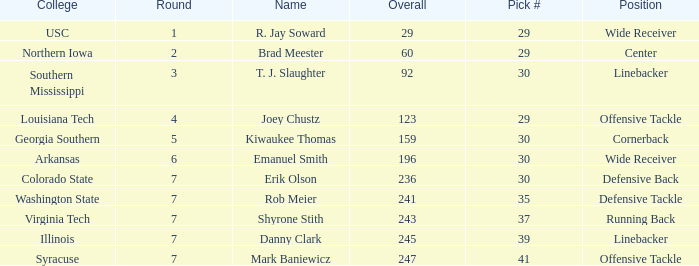What is the highest Pick that is wide receiver with overall of 29? 29.0. 